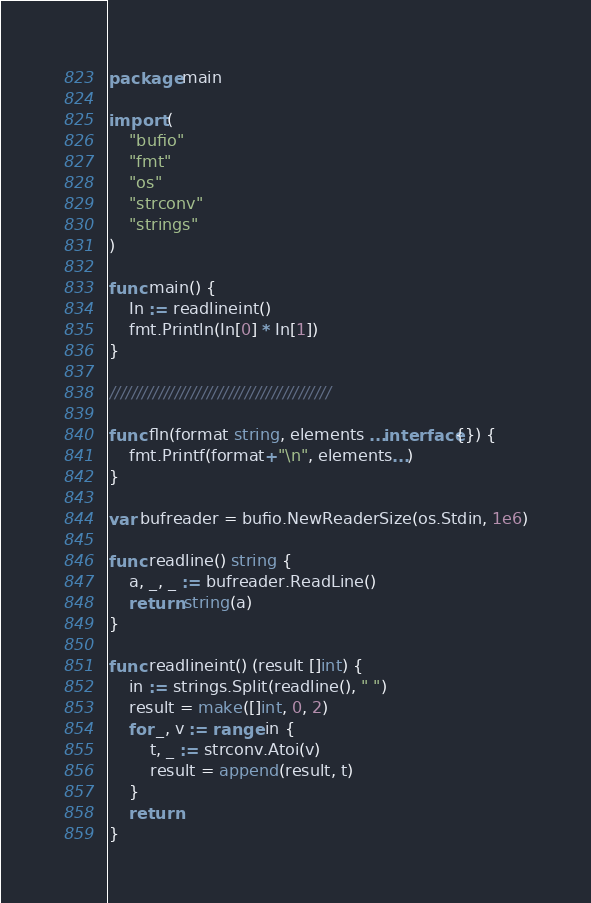Convert code to text. <code><loc_0><loc_0><loc_500><loc_500><_Go_>package main

import (
	"bufio"
	"fmt"
	"os"
	"strconv"
	"strings"
)

func main() {
	In := readlineint()
	fmt.Println(In[0] * In[1])
}

/////////////////////////////////////////

func fln(format string, elements ...interface{}) {
	fmt.Printf(format+"\n", elements...)
}

var bufreader = bufio.NewReaderSize(os.Stdin, 1e6)

func readline() string {
	a, _, _ := bufreader.ReadLine()
	return string(a)
}

func readlineint() (result []int) {
	in := strings.Split(readline(), " ")
	result = make([]int, 0, 2)
	for _, v := range in {
		t, _ := strconv.Atoi(v)
		result = append(result, t)
	}
	return
}</code> 